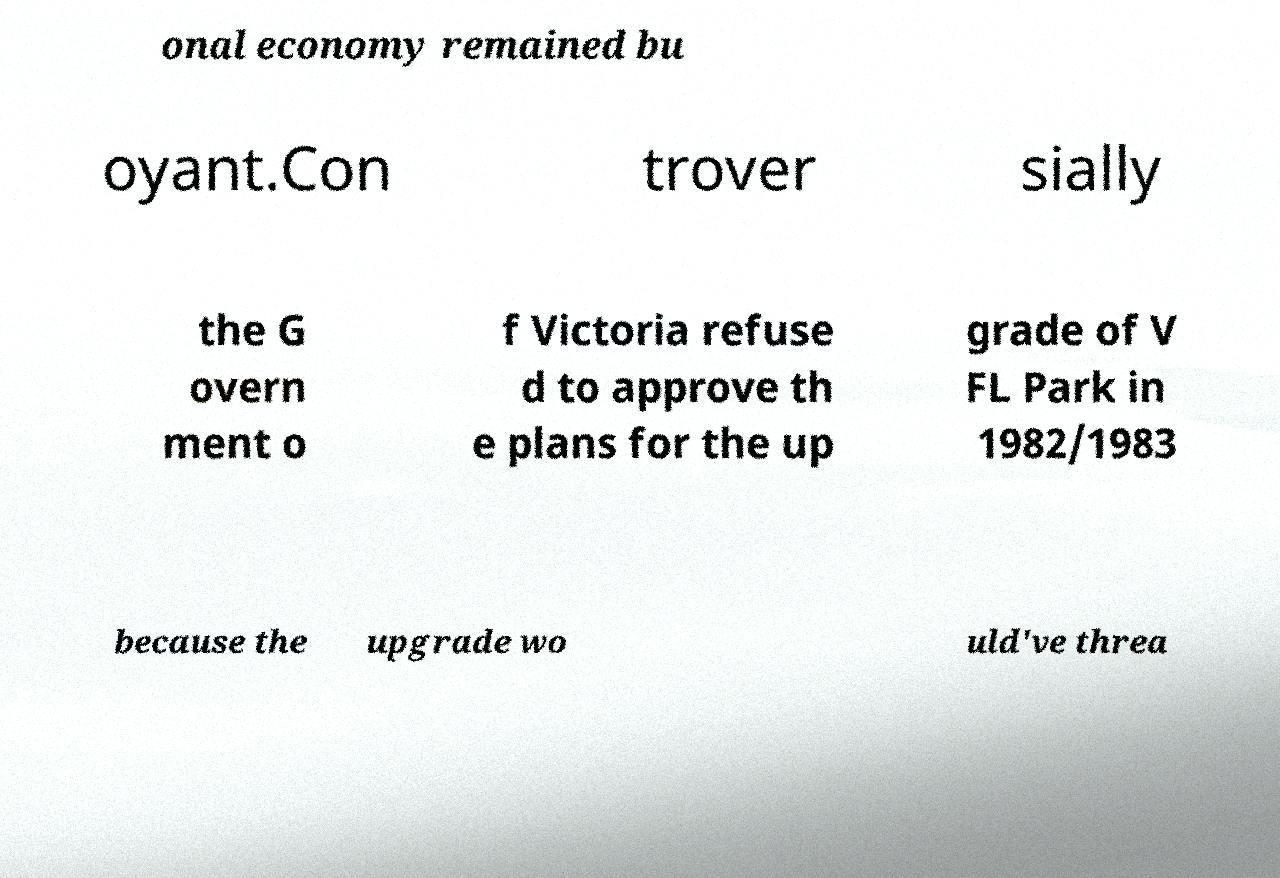Can you read and provide the text displayed in the image?This photo seems to have some interesting text. Can you extract and type it out for me? onal economy remained bu oyant.Con trover sially the G overn ment o f Victoria refuse d to approve th e plans for the up grade of V FL Park in 1982/1983 because the upgrade wo uld've threa 